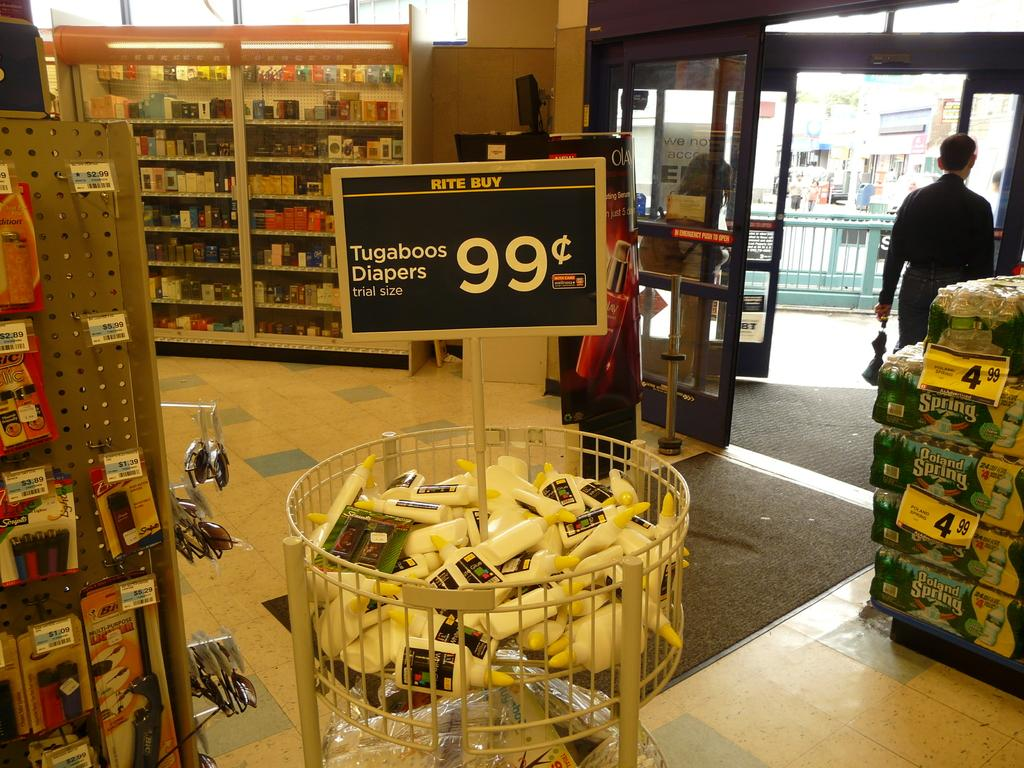<image>
Present a compact description of the photo's key features. A display for Tugaboos Diapers priced at 99 cents each 